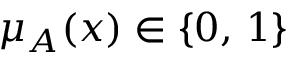<formula> <loc_0><loc_0><loc_500><loc_500>\mu _ { A } ( x ) \in \{ 0 , \, 1 \}</formula> 